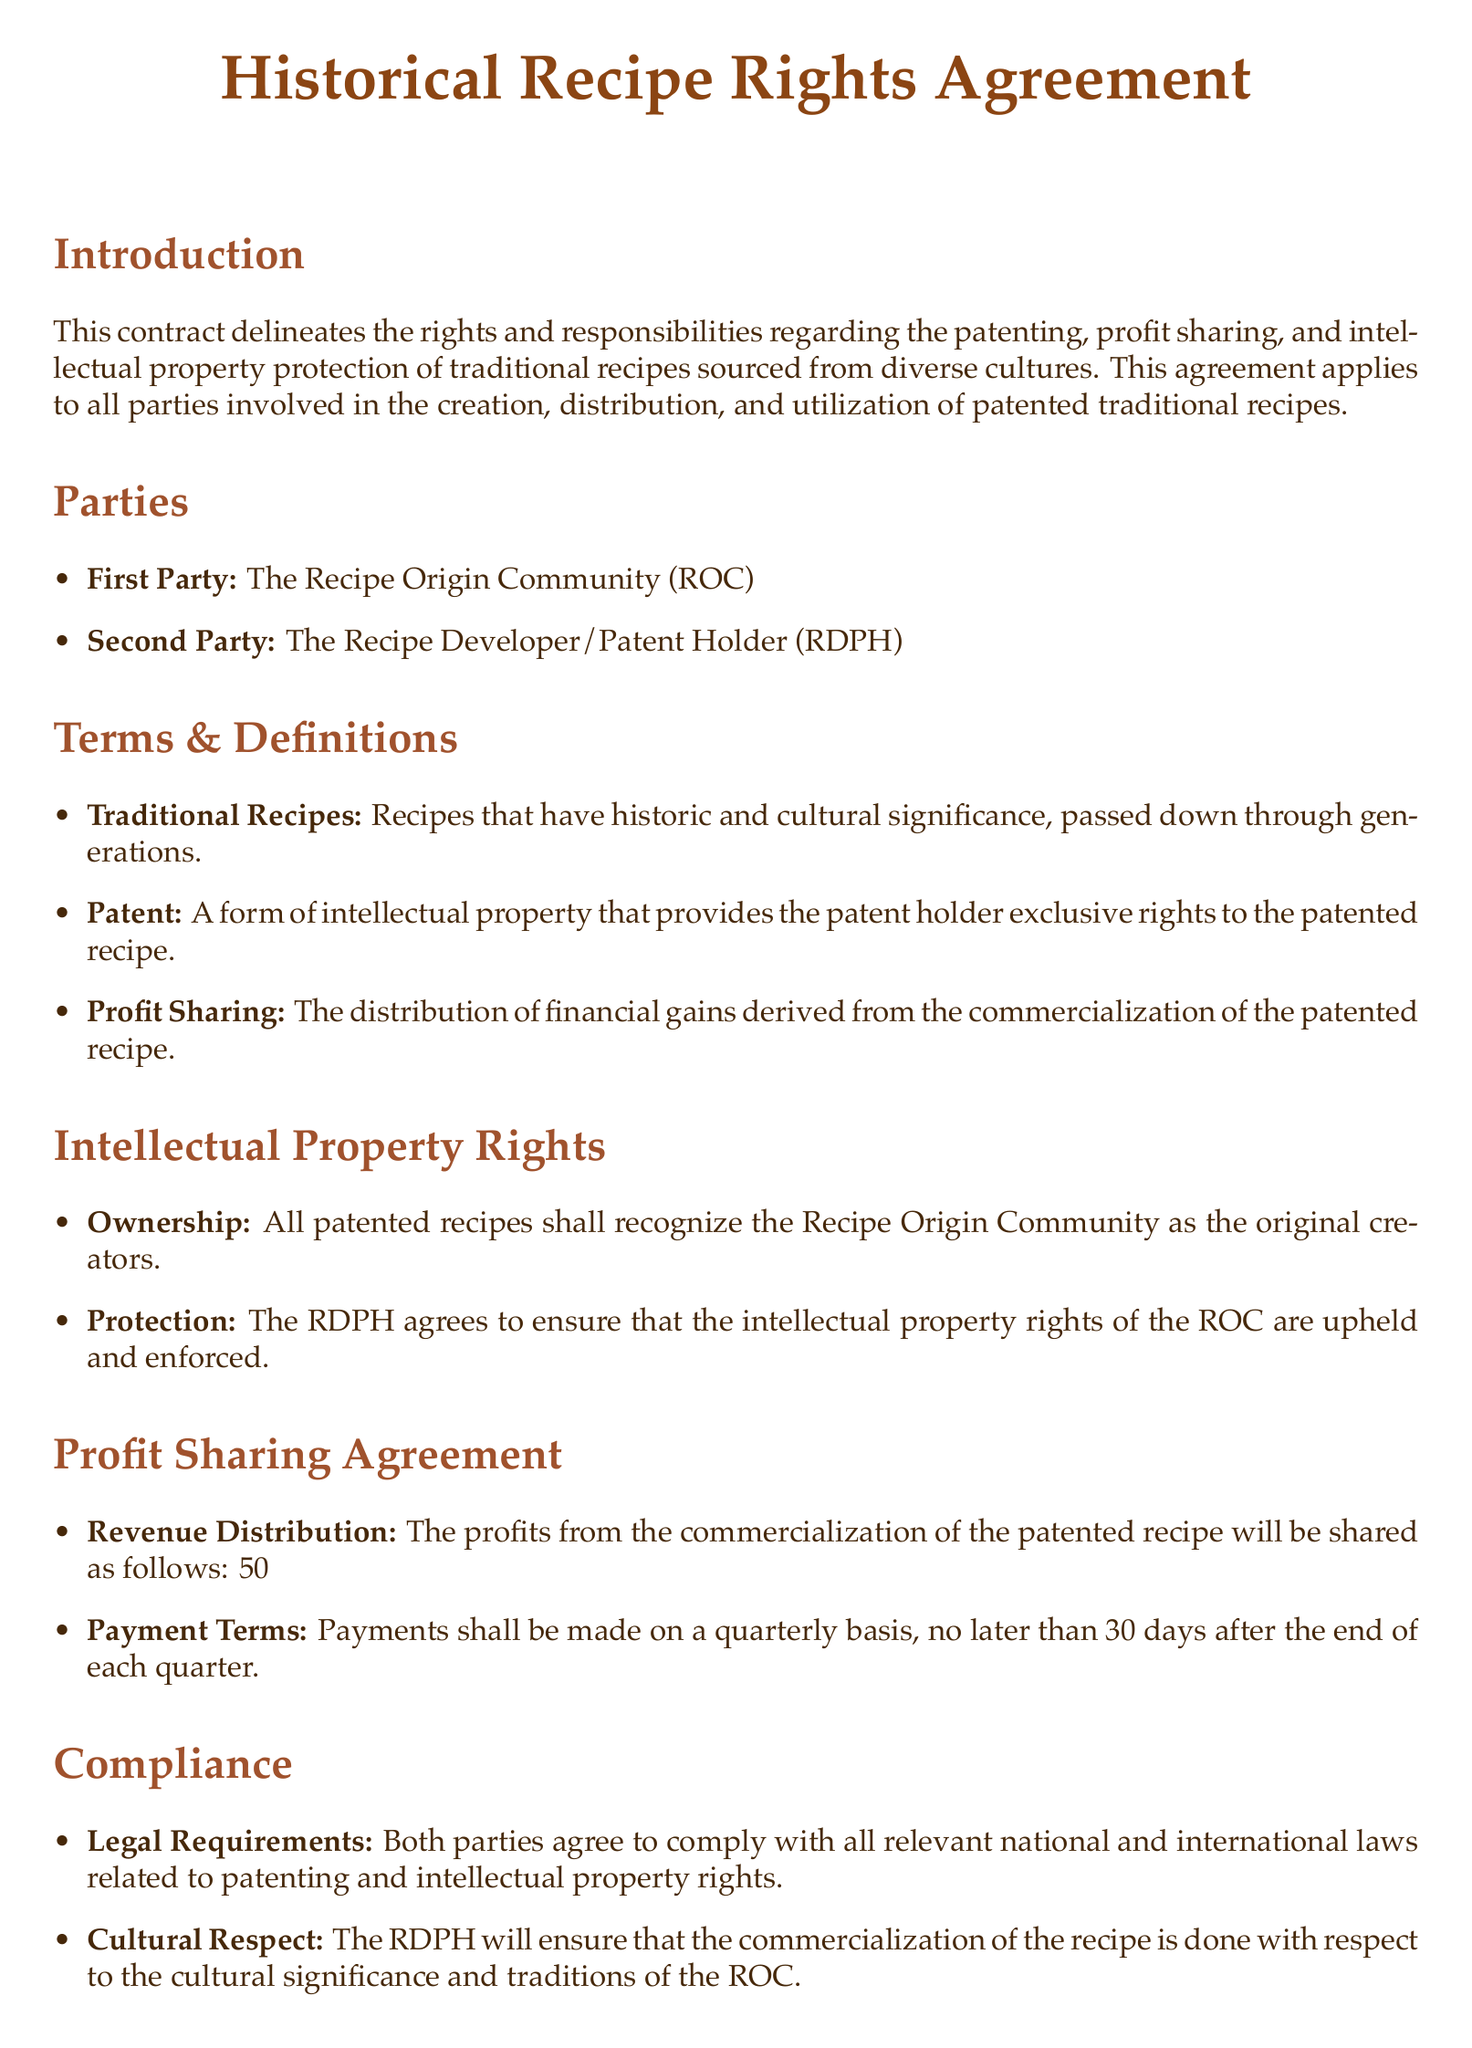What are the parties involved in the agreement? The parties involved in the agreement are identified in the document under the "Parties" section: the Recipe Origin Community and the Recipe Developer/Patent Holder.
Answer: Recipe Origin Community and Recipe Developer/Patent Holder What is defined as a traditional recipe? The document defines traditional recipes in the "Terms & Definitions" section as recipes that have historic and cultural significance, passed down through generations.
Answer: Recipes that have historic and cultural significance, passed down through generations What percentage of profits does the Recipe Origin Community receive? The profit-sharing terms state that the profits will be shared equally between the two parties, which means the Recipe Origin Community gets 50 percent.
Answer: 50% What is the payment term for profit sharing? According to the "Payment Terms," payments shall be made no later than 30 days after the end of each quarter.
Answer: 30 days What type of dispute resolution is preferred? The document mentions that disputes should be resolved through mediation or arbitration, with a preference for culturally sensitive practices.
Answer: Culturally sensitive practices Who is responsible for protecting intellectual property rights? The agreement states that the Recipe Developer/Patent Holder agrees to uphold and enforce the intellectual property rights of the Recipe Origin Community, indicating their responsibility.
Answer: Recipe Developer/Patent Holder What is the minimum notice period for termination? The termination clause states that either party may terminate the agreement with a 90-day written notice.
Answer: 90 days What does the Recipe Developer/Patent Holder have to consider regarding commercialization? The agreement emphasizes that the Recipe Developer/Patent Holder must ensure the commercialization is done with respect to the cultural significance and traditions of the Recipe Origin Community.
Answer: Cultural significance and traditions How often are revenue distributions set to occur? According to the "Profit Sharing Agreement," revenue distributions are set to occur on a quarterly basis.
Answer: Quarterly basis 